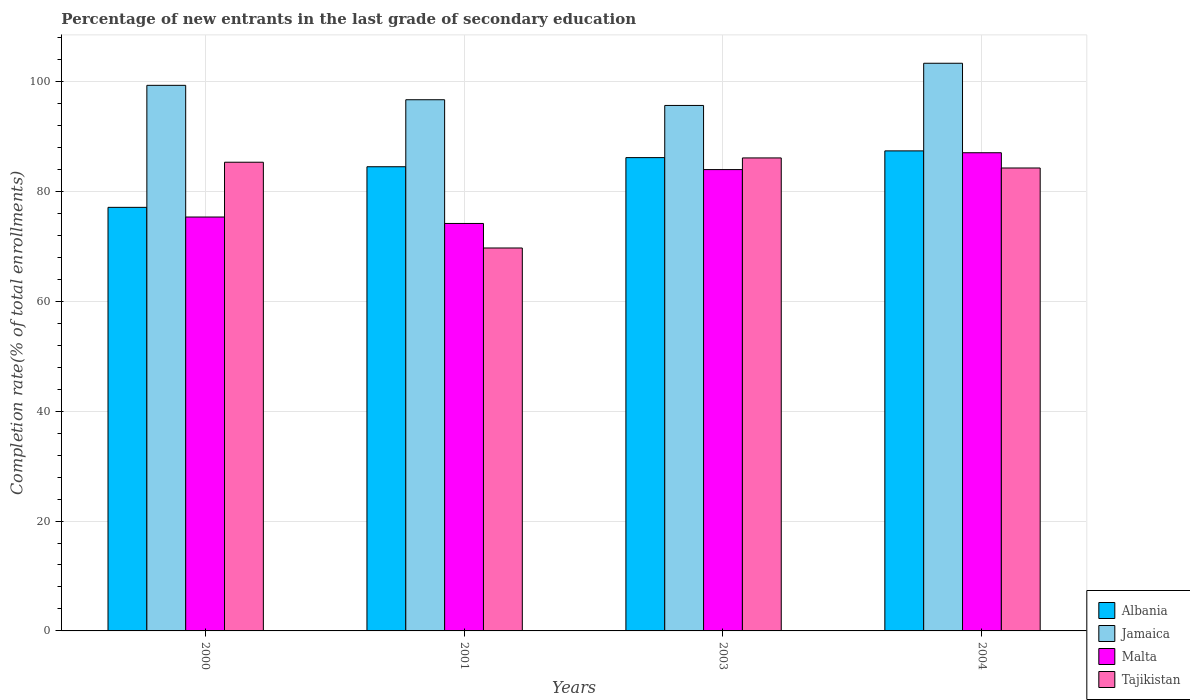Are the number of bars on each tick of the X-axis equal?
Offer a terse response. Yes. How many bars are there on the 2nd tick from the left?
Ensure brevity in your answer.  4. What is the percentage of new entrants in Tajikistan in 2004?
Your answer should be compact. 84.25. Across all years, what is the maximum percentage of new entrants in Albania?
Your response must be concise. 87.37. Across all years, what is the minimum percentage of new entrants in Jamaica?
Ensure brevity in your answer.  95.64. What is the total percentage of new entrants in Malta in the graph?
Your answer should be compact. 320.47. What is the difference between the percentage of new entrants in Tajikistan in 2003 and that in 2004?
Your response must be concise. 1.83. What is the difference between the percentage of new entrants in Albania in 2001 and the percentage of new entrants in Malta in 2004?
Keep it short and to the point. -2.55. What is the average percentage of new entrants in Malta per year?
Keep it short and to the point. 80.12. In the year 2003, what is the difference between the percentage of new entrants in Tajikistan and percentage of new entrants in Malta?
Offer a very short reply. 2.12. What is the ratio of the percentage of new entrants in Malta in 2000 to that in 2004?
Your response must be concise. 0.87. Is the difference between the percentage of new entrants in Tajikistan in 2001 and 2003 greater than the difference between the percentage of new entrants in Malta in 2001 and 2003?
Give a very brief answer. No. What is the difference between the highest and the second highest percentage of new entrants in Tajikistan?
Your answer should be compact. 0.78. What is the difference between the highest and the lowest percentage of new entrants in Jamaica?
Ensure brevity in your answer.  7.68. In how many years, is the percentage of new entrants in Jamaica greater than the average percentage of new entrants in Jamaica taken over all years?
Offer a very short reply. 2. What does the 1st bar from the left in 2000 represents?
Make the answer very short. Albania. What does the 4th bar from the right in 2003 represents?
Your response must be concise. Albania. Is it the case that in every year, the sum of the percentage of new entrants in Albania and percentage of new entrants in Jamaica is greater than the percentage of new entrants in Malta?
Your response must be concise. Yes. How many bars are there?
Make the answer very short. 16. How many years are there in the graph?
Ensure brevity in your answer.  4. What is the difference between two consecutive major ticks on the Y-axis?
Offer a terse response. 20. Does the graph contain any zero values?
Your answer should be very brief. No. Does the graph contain grids?
Offer a very short reply. Yes. How are the legend labels stacked?
Keep it short and to the point. Vertical. What is the title of the graph?
Offer a terse response. Percentage of new entrants in the last grade of secondary education. What is the label or title of the X-axis?
Give a very brief answer. Years. What is the label or title of the Y-axis?
Provide a short and direct response. Completion rate(% of total enrollments). What is the Completion rate(% of total enrollments) in Albania in 2000?
Your answer should be compact. 77.09. What is the Completion rate(% of total enrollments) in Jamaica in 2000?
Give a very brief answer. 99.3. What is the Completion rate(% of total enrollments) of Malta in 2000?
Ensure brevity in your answer.  75.33. What is the Completion rate(% of total enrollments) of Tajikistan in 2000?
Ensure brevity in your answer.  85.3. What is the Completion rate(% of total enrollments) of Albania in 2001?
Offer a very short reply. 84.48. What is the Completion rate(% of total enrollments) in Jamaica in 2001?
Offer a very short reply. 96.68. What is the Completion rate(% of total enrollments) of Malta in 2001?
Offer a very short reply. 74.16. What is the Completion rate(% of total enrollments) in Tajikistan in 2001?
Give a very brief answer. 69.69. What is the Completion rate(% of total enrollments) in Albania in 2003?
Provide a succinct answer. 86.14. What is the Completion rate(% of total enrollments) in Jamaica in 2003?
Offer a very short reply. 95.64. What is the Completion rate(% of total enrollments) in Malta in 2003?
Your answer should be very brief. 83.96. What is the Completion rate(% of total enrollments) of Tajikistan in 2003?
Ensure brevity in your answer.  86.09. What is the Completion rate(% of total enrollments) of Albania in 2004?
Make the answer very short. 87.37. What is the Completion rate(% of total enrollments) in Jamaica in 2004?
Offer a very short reply. 103.31. What is the Completion rate(% of total enrollments) of Malta in 2004?
Provide a short and direct response. 87.03. What is the Completion rate(% of total enrollments) of Tajikistan in 2004?
Offer a terse response. 84.25. Across all years, what is the maximum Completion rate(% of total enrollments) of Albania?
Provide a succinct answer. 87.37. Across all years, what is the maximum Completion rate(% of total enrollments) of Jamaica?
Make the answer very short. 103.31. Across all years, what is the maximum Completion rate(% of total enrollments) of Malta?
Your response must be concise. 87.03. Across all years, what is the maximum Completion rate(% of total enrollments) of Tajikistan?
Your answer should be compact. 86.09. Across all years, what is the minimum Completion rate(% of total enrollments) of Albania?
Provide a short and direct response. 77.09. Across all years, what is the minimum Completion rate(% of total enrollments) of Jamaica?
Keep it short and to the point. 95.64. Across all years, what is the minimum Completion rate(% of total enrollments) of Malta?
Ensure brevity in your answer.  74.16. Across all years, what is the minimum Completion rate(% of total enrollments) of Tajikistan?
Offer a terse response. 69.69. What is the total Completion rate(% of total enrollments) of Albania in the graph?
Ensure brevity in your answer.  335.08. What is the total Completion rate(% of total enrollments) in Jamaica in the graph?
Ensure brevity in your answer.  394.92. What is the total Completion rate(% of total enrollments) in Malta in the graph?
Provide a short and direct response. 320.47. What is the total Completion rate(% of total enrollments) in Tajikistan in the graph?
Your response must be concise. 325.33. What is the difference between the Completion rate(% of total enrollments) in Albania in 2000 and that in 2001?
Make the answer very short. -7.39. What is the difference between the Completion rate(% of total enrollments) in Jamaica in 2000 and that in 2001?
Your response must be concise. 2.62. What is the difference between the Completion rate(% of total enrollments) of Malta in 2000 and that in 2001?
Ensure brevity in your answer.  1.17. What is the difference between the Completion rate(% of total enrollments) of Tajikistan in 2000 and that in 2001?
Offer a very short reply. 15.61. What is the difference between the Completion rate(% of total enrollments) of Albania in 2000 and that in 2003?
Give a very brief answer. -9.05. What is the difference between the Completion rate(% of total enrollments) in Jamaica in 2000 and that in 2003?
Make the answer very short. 3.66. What is the difference between the Completion rate(% of total enrollments) of Malta in 2000 and that in 2003?
Your answer should be compact. -8.63. What is the difference between the Completion rate(% of total enrollments) of Tajikistan in 2000 and that in 2003?
Your answer should be compact. -0.78. What is the difference between the Completion rate(% of total enrollments) in Albania in 2000 and that in 2004?
Make the answer very short. -10.28. What is the difference between the Completion rate(% of total enrollments) of Jamaica in 2000 and that in 2004?
Your answer should be compact. -4.02. What is the difference between the Completion rate(% of total enrollments) in Malta in 2000 and that in 2004?
Offer a terse response. -11.7. What is the difference between the Completion rate(% of total enrollments) in Tajikistan in 2000 and that in 2004?
Ensure brevity in your answer.  1.05. What is the difference between the Completion rate(% of total enrollments) in Albania in 2001 and that in 2003?
Provide a short and direct response. -1.66. What is the difference between the Completion rate(% of total enrollments) in Jamaica in 2001 and that in 2003?
Your response must be concise. 1.04. What is the difference between the Completion rate(% of total enrollments) in Malta in 2001 and that in 2003?
Your answer should be very brief. -9.81. What is the difference between the Completion rate(% of total enrollments) in Tajikistan in 2001 and that in 2003?
Give a very brief answer. -16.39. What is the difference between the Completion rate(% of total enrollments) of Albania in 2001 and that in 2004?
Keep it short and to the point. -2.88. What is the difference between the Completion rate(% of total enrollments) of Jamaica in 2001 and that in 2004?
Give a very brief answer. -6.64. What is the difference between the Completion rate(% of total enrollments) in Malta in 2001 and that in 2004?
Your response must be concise. -12.87. What is the difference between the Completion rate(% of total enrollments) of Tajikistan in 2001 and that in 2004?
Offer a terse response. -14.56. What is the difference between the Completion rate(% of total enrollments) in Albania in 2003 and that in 2004?
Offer a very short reply. -1.23. What is the difference between the Completion rate(% of total enrollments) in Jamaica in 2003 and that in 2004?
Give a very brief answer. -7.68. What is the difference between the Completion rate(% of total enrollments) in Malta in 2003 and that in 2004?
Keep it short and to the point. -3.07. What is the difference between the Completion rate(% of total enrollments) in Tajikistan in 2003 and that in 2004?
Offer a very short reply. 1.83. What is the difference between the Completion rate(% of total enrollments) in Albania in 2000 and the Completion rate(% of total enrollments) in Jamaica in 2001?
Offer a terse response. -19.59. What is the difference between the Completion rate(% of total enrollments) in Albania in 2000 and the Completion rate(% of total enrollments) in Malta in 2001?
Make the answer very short. 2.93. What is the difference between the Completion rate(% of total enrollments) in Albania in 2000 and the Completion rate(% of total enrollments) in Tajikistan in 2001?
Your response must be concise. 7.4. What is the difference between the Completion rate(% of total enrollments) in Jamaica in 2000 and the Completion rate(% of total enrollments) in Malta in 2001?
Keep it short and to the point. 25.14. What is the difference between the Completion rate(% of total enrollments) of Jamaica in 2000 and the Completion rate(% of total enrollments) of Tajikistan in 2001?
Your answer should be compact. 29.6. What is the difference between the Completion rate(% of total enrollments) of Malta in 2000 and the Completion rate(% of total enrollments) of Tajikistan in 2001?
Ensure brevity in your answer.  5.64. What is the difference between the Completion rate(% of total enrollments) of Albania in 2000 and the Completion rate(% of total enrollments) of Jamaica in 2003?
Give a very brief answer. -18.55. What is the difference between the Completion rate(% of total enrollments) in Albania in 2000 and the Completion rate(% of total enrollments) in Malta in 2003?
Keep it short and to the point. -6.87. What is the difference between the Completion rate(% of total enrollments) in Albania in 2000 and the Completion rate(% of total enrollments) in Tajikistan in 2003?
Provide a short and direct response. -9. What is the difference between the Completion rate(% of total enrollments) of Jamaica in 2000 and the Completion rate(% of total enrollments) of Malta in 2003?
Your answer should be compact. 15.33. What is the difference between the Completion rate(% of total enrollments) in Jamaica in 2000 and the Completion rate(% of total enrollments) in Tajikistan in 2003?
Offer a terse response. 13.21. What is the difference between the Completion rate(% of total enrollments) in Malta in 2000 and the Completion rate(% of total enrollments) in Tajikistan in 2003?
Provide a short and direct response. -10.76. What is the difference between the Completion rate(% of total enrollments) in Albania in 2000 and the Completion rate(% of total enrollments) in Jamaica in 2004?
Your response must be concise. -26.22. What is the difference between the Completion rate(% of total enrollments) in Albania in 2000 and the Completion rate(% of total enrollments) in Malta in 2004?
Your answer should be very brief. -9.94. What is the difference between the Completion rate(% of total enrollments) in Albania in 2000 and the Completion rate(% of total enrollments) in Tajikistan in 2004?
Your answer should be very brief. -7.16. What is the difference between the Completion rate(% of total enrollments) of Jamaica in 2000 and the Completion rate(% of total enrollments) of Malta in 2004?
Give a very brief answer. 12.27. What is the difference between the Completion rate(% of total enrollments) of Jamaica in 2000 and the Completion rate(% of total enrollments) of Tajikistan in 2004?
Offer a very short reply. 15.04. What is the difference between the Completion rate(% of total enrollments) in Malta in 2000 and the Completion rate(% of total enrollments) in Tajikistan in 2004?
Provide a short and direct response. -8.92. What is the difference between the Completion rate(% of total enrollments) in Albania in 2001 and the Completion rate(% of total enrollments) in Jamaica in 2003?
Provide a succinct answer. -11.15. What is the difference between the Completion rate(% of total enrollments) of Albania in 2001 and the Completion rate(% of total enrollments) of Malta in 2003?
Ensure brevity in your answer.  0.52. What is the difference between the Completion rate(% of total enrollments) of Albania in 2001 and the Completion rate(% of total enrollments) of Tajikistan in 2003?
Your answer should be very brief. -1.6. What is the difference between the Completion rate(% of total enrollments) of Jamaica in 2001 and the Completion rate(% of total enrollments) of Malta in 2003?
Offer a terse response. 12.71. What is the difference between the Completion rate(% of total enrollments) in Jamaica in 2001 and the Completion rate(% of total enrollments) in Tajikistan in 2003?
Offer a very short reply. 10.59. What is the difference between the Completion rate(% of total enrollments) in Malta in 2001 and the Completion rate(% of total enrollments) in Tajikistan in 2003?
Provide a succinct answer. -11.93. What is the difference between the Completion rate(% of total enrollments) in Albania in 2001 and the Completion rate(% of total enrollments) in Jamaica in 2004?
Provide a succinct answer. -18.83. What is the difference between the Completion rate(% of total enrollments) in Albania in 2001 and the Completion rate(% of total enrollments) in Malta in 2004?
Keep it short and to the point. -2.55. What is the difference between the Completion rate(% of total enrollments) of Albania in 2001 and the Completion rate(% of total enrollments) of Tajikistan in 2004?
Keep it short and to the point. 0.23. What is the difference between the Completion rate(% of total enrollments) in Jamaica in 2001 and the Completion rate(% of total enrollments) in Malta in 2004?
Offer a terse response. 9.65. What is the difference between the Completion rate(% of total enrollments) in Jamaica in 2001 and the Completion rate(% of total enrollments) in Tajikistan in 2004?
Your answer should be very brief. 12.42. What is the difference between the Completion rate(% of total enrollments) of Malta in 2001 and the Completion rate(% of total enrollments) of Tajikistan in 2004?
Ensure brevity in your answer.  -10.1. What is the difference between the Completion rate(% of total enrollments) in Albania in 2003 and the Completion rate(% of total enrollments) in Jamaica in 2004?
Offer a very short reply. -17.17. What is the difference between the Completion rate(% of total enrollments) in Albania in 2003 and the Completion rate(% of total enrollments) in Malta in 2004?
Offer a very short reply. -0.89. What is the difference between the Completion rate(% of total enrollments) of Albania in 2003 and the Completion rate(% of total enrollments) of Tajikistan in 2004?
Offer a terse response. 1.89. What is the difference between the Completion rate(% of total enrollments) of Jamaica in 2003 and the Completion rate(% of total enrollments) of Malta in 2004?
Offer a terse response. 8.61. What is the difference between the Completion rate(% of total enrollments) of Jamaica in 2003 and the Completion rate(% of total enrollments) of Tajikistan in 2004?
Give a very brief answer. 11.38. What is the difference between the Completion rate(% of total enrollments) in Malta in 2003 and the Completion rate(% of total enrollments) in Tajikistan in 2004?
Offer a terse response. -0.29. What is the average Completion rate(% of total enrollments) of Albania per year?
Offer a very short reply. 83.77. What is the average Completion rate(% of total enrollments) of Jamaica per year?
Offer a very short reply. 98.73. What is the average Completion rate(% of total enrollments) of Malta per year?
Offer a terse response. 80.12. What is the average Completion rate(% of total enrollments) in Tajikistan per year?
Make the answer very short. 81.33. In the year 2000, what is the difference between the Completion rate(% of total enrollments) in Albania and Completion rate(% of total enrollments) in Jamaica?
Ensure brevity in your answer.  -22.21. In the year 2000, what is the difference between the Completion rate(% of total enrollments) of Albania and Completion rate(% of total enrollments) of Malta?
Offer a terse response. 1.76. In the year 2000, what is the difference between the Completion rate(% of total enrollments) of Albania and Completion rate(% of total enrollments) of Tajikistan?
Make the answer very short. -8.21. In the year 2000, what is the difference between the Completion rate(% of total enrollments) of Jamaica and Completion rate(% of total enrollments) of Malta?
Provide a succinct answer. 23.97. In the year 2000, what is the difference between the Completion rate(% of total enrollments) of Jamaica and Completion rate(% of total enrollments) of Tajikistan?
Your answer should be very brief. 13.99. In the year 2000, what is the difference between the Completion rate(% of total enrollments) of Malta and Completion rate(% of total enrollments) of Tajikistan?
Offer a very short reply. -9.97. In the year 2001, what is the difference between the Completion rate(% of total enrollments) of Albania and Completion rate(% of total enrollments) of Jamaica?
Your answer should be very brief. -12.19. In the year 2001, what is the difference between the Completion rate(% of total enrollments) in Albania and Completion rate(% of total enrollments) in Malta?
Ensure brevity in your answer.  10.33. In the year 2001, what is the difference between the Completion rate(% of total enrollments) of Albania and Completion rate(% of total enrollments) of Tajikistan?
Your response must be concise. 14.79. In the year 2001, what is the difference between the Completion rate(% of total enrollments) of Jamaica and Completion rate(% of total enrollments) of Malta?
Make the answer very short. 22.52. In the year 2001, what is the difference between the Completion rate(% of total enrollments) of Jamaica and Completion rate(% of total enrollments) of Tajikistan?
Your answer should be very brief. 26.98. In the year 2001, what is the difference between the Completion rate(% of total enrollments) in Malta and Completion rate(% of total enrollments) in Tajikistan?
Make the answer very short. 4.46. In the year 2003, what is the difference between the Completion rate(% of total enrollments) of Albania and Completion rate(% of total enrollments) of Jamaica?
Give a very brief answer. -9.5. In the year 2003, what is the difference between the Completion rate(% of total enrollments) in Albania and Completion rate(% of total enrollments) in Malta?
Give a very brief answer. 2.18. In the year 2003, what is the difference between the Completion rate(% of total enrollments) of Albania and Completion rate(% of total enrollments) of Tajikistan?
Your answer should be compact. 0.05. In the year 2003, what is the difference between the Completion rate(% of total enrollments) in Jamaica and Completion rate(% of total enrollments) in Malta?
Your answer should be compact. 11.67. In the year 2003, what is the difference between the Completion rate(% of total enrollments) in Jamaica and Completion rate(% of total enrollments) in Tajikistan?
Provide a succinct answer. 9.55. In the year 2003, what is the difference between the Completion rate(% of total enrollments) of Malta and Completion rate(% of total enrollments) of Tajikistan?
Ensure brevity in your answer.  -2.12. In the year 2004, what is the difference between the Completion rate(% of total enrollments) in Albania and Completion rate(% of total enrollments) in Jamaica?
Provide a succinct answer. -15.95. In the year 2004, what is the difference between the Completion rate(% of total enrollments) in Albania and Completion rate(% of total enrollments) in Malta?
Ensure brevity in your answer.  0.34. In the year 2004, what is the difference between the Completion rate(% of total enrollments) in Albania and Completion rate(% of total enrollments) in Tajikistan?
Your answer should be very brief. 3.11. In the year 2004, what is the difference between the Completion rate(% of total enrollments) in Jamaica and Completion rate(% of total enrollments) in Malta?
Offer a terse response. 16.29. In the year 2004, what is the difference between the Completion rate(% of total enrollments) of Jamaica and Completion rate(% of total enrollments) of Tajikistan?
Make the answer very short. 19.06. In the year 2004, what is the difference between the Completion rate(% of total enrollments) of Malta and Completion rate(% of total enrollments) of Tajikistan?
Your answer should be very brief. 2.77. What is the ratio of the Completion rate(% of total enrollments) of Albania in 2000 to that in 2001?
Offer a very short reply. 0.91. What is the ratio of the Completion rate(% of total enrollments) in Jamaica in 2000 to that in 2001?
Ensure brevity in your answer.  1.03. What is the ratio of the Completion rate(% of total enrollments) in Malta in 2000 to that in 2001?
Your response must be concise. 1.02. What is the ratio of the Completion rate(% of total enrollments) in Tajikistan in 2000 to that in 2001?
Your response must be concise. 1.22. What is the ratio of the Completion rate(% of total enrollments) of Albania in 2000 to that in 2003?
Make the answer very short. 0.89. What is the ratio of the Completion rate(% of total enrollments) in Jamaica in 2000 to that in 2003?
Provide a succinct answer. 1.04. What is the ratio of the Completion rate(% of total enrollments) of Malta in 2000 to that in 2003?
Offer a very short reply. 0.9. What is the ratio of the Completion rate(% of total enrollments) of Tajikistan in 2000 to that in 2003?
Keep it short and to the point. 0.99. What is the ratio of the Completion rate(% of total enrollments) in Albania in 2000 to that in 2004?
Ensure brevity in your answer.  0.88. What is the ratio of the Completion rate(% of total enrollments) in Jamaica in 2000 to that in 2004?
Make the answer very short. 0.96. What is the ratio of the Completion rate(% of total enrollments) of Malta in 2000 to that in 2004?
Your answer should be compact. 0.87. What is the ratio of the Completion rate(% of total enrollments) of Tajikistan in 2000 to that in 2004?
Offer a very short reply. 1.01. What is the ratio of the Completion rate(% of total enrollments) in Albania in 2001 to that in 2003?
Offer a terse response. 0.98. What is the ratio of the Completion rate(% of total enrollments) in Jamaica in 2001 to that in 2003?
Keep it short and to the point. 1.01. What is the ratio of the Completion rate(% of total enrollments) of Malta in 2001 to that in 2003?
Make the answer very short. 0.88. What is the ratio of the Completion rate(% of total enrollments) in Tajikistan in 2001 to that in 2003?
Provide a succinct answer. 0.81. What is the ratio of the Completion rate(% of total enrollments) of Jamaica in 2001 to that in 2004?
Keep it short and to the point. 0.94. What is the ratio of the Completion rate(% of total enrollments) of Malta in 2001 to that in 2004?
Offer a very short reply. 0.85. What is the ratio of the Completion rate(% of total enrollments) in Tajikistan in 2001 to that in 2004?
Provide a short and direct response. 0.83. What is the ratio of the Completion rate(% of total enrollments) in Jamaica in 2003 to that in 2004?
Your answer should be very brief. 0.93. What is the ratio of the Completion rate(% of total enrollments) in Malta in 2003 to that in 2004?
Your response must be concise. 0.96. What is the ratio of the Completion rate(% of total enrollments) in Tajikistan in 2003 to that in 2004?
Provide a succinct answer. 1.02. What is the difference between the highest and the second highest Completion rate(% of total enrollments) in Albania?
Provide a short and direct response. 1.23. What is the difference between the highest and the second highest Completion rate(% of total enrollments) in Jamaica?
Your response must be concise. 4.02. What is the difference between the highest and the second highest Completion rate(% of total enrollments) of Malta?
Give a very brief answer. 3.07. What is the difference between the highest and the second highest Completion rate(% of total enrollments) in Tajikistan?
Ensure brevity in your answer.  0.78. What is the difference between the highest and the lowest Completion rate(% of total enrollments) in Albania?
Your answer should be very brief. 10.28. What is the difference between the highest and the lowest Completion rate(% of total enrollments) in Jamaica?
Offer a very short reply. 7.68. What is the difference between the highest and the lowest Completion rate(% of total enrollments) of Malta?
Keep it short and to the point. 12.87. What is the difference between the highest and the lowest Completion rate(% of total enrollments) in Tajikistan?
Your answer should be very brief. 16.39. 